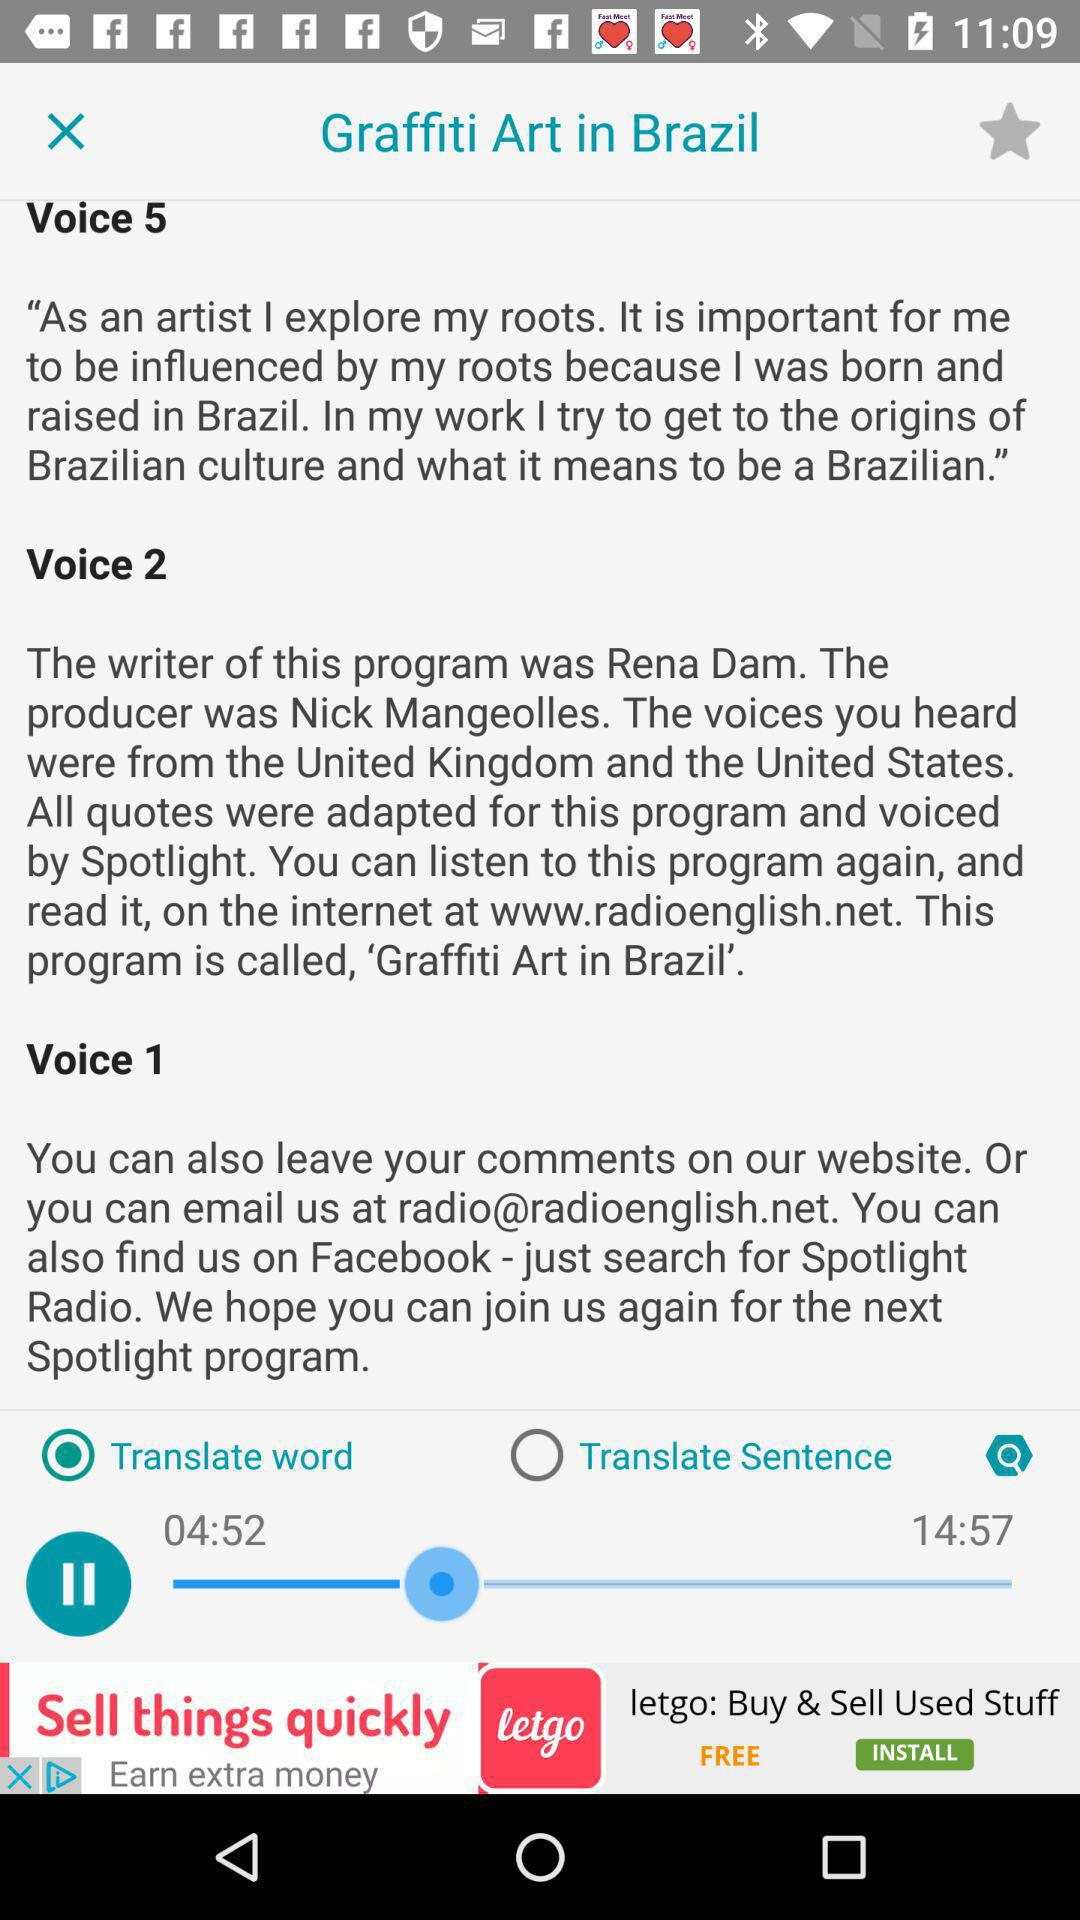What is the name of the program? The name of the program is "Graffiti Art in Brazil". 